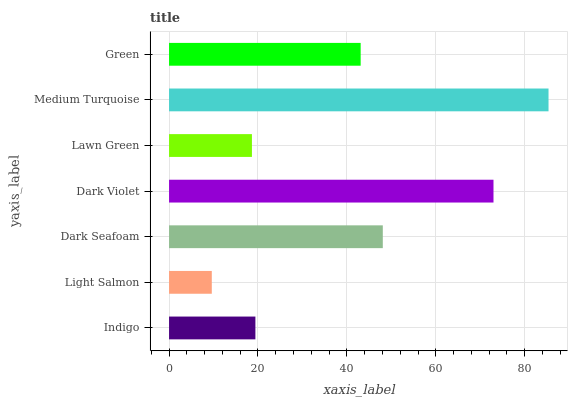Is Light Salmon the minimum?
Answer yes or no. Yes. Is Medium Turquoise the maximum?
Answer yes or no. Yes. Is Dark Seafoam the minimum?
Answer yes or no. No. Is Dark Seafoam the maximum?
Answer yes or no. No. Is Dark Seafoam greater than Light Salmon?
Answer yes or no. Yes. Is Light Salmon less than Dark Seafoam?
Answer yes or no. Yes. Is Light Salmon greater than Dark Seafoam?
Answer yes or no. No. Is Dark Seafoam less than Light Salmon?
Answer yes or no. No. Is Green the high median?
Answer yes or no. Yes. Is Green the low median?
Answer yes or no. Yes. Is Medium Turquoise the high median?
Answer yes or no. No. Is Indigo the low median?
Answer yes or no. No. 